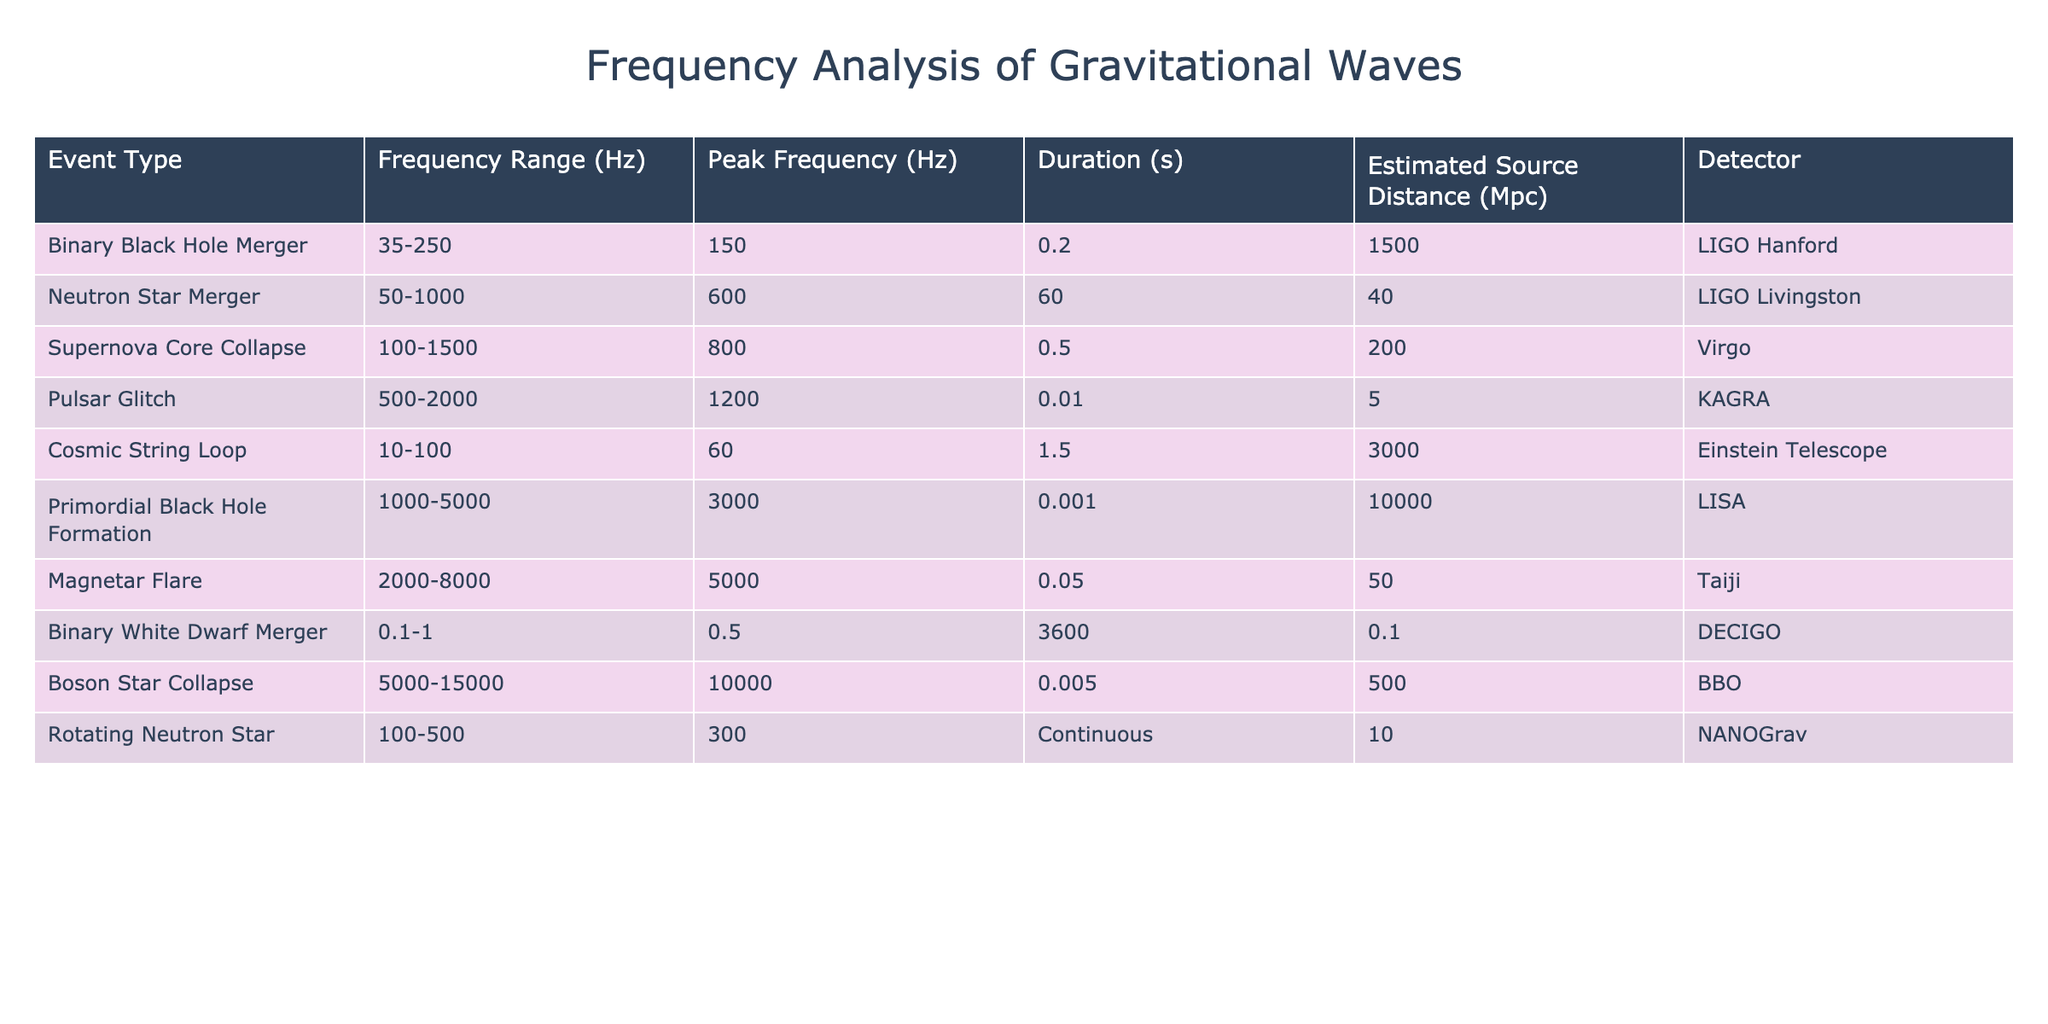What is the peak frequency of the Neutron Star Merger? The table lists the Neutron Star Merger under the "Event Type" with a corresponding "Peak Frequency" of 600 Hz.
Answer: 600 Hz How many events have a duration longer than 1 second? Upon examining the "Duration" column, the events with longer durations are Binary White Dwarf Merger (3600 seconds), Cosmic String Loop (1.5 seconds), and Neutron Star Merger (60 seconds) totaling 3 events.
Answer: 3 Is the peak frequency of the Pulsar Glitch greater than that of the Supernova Core Collapse? The Pulsar Glitch has a peak frequency of 1200 Hz while the Supernova Core Collapse has a peak frequency of 800 Hz. Since 1200 Hz is greater than 800 Hz, the answer is yes.
Answer: Yes What is the difference in peak frequency between the highest and lowest frequency events? The event with the lowest peak frequency is the Binary White Dwarf Merger at 0.5 Hz, and the highest is the Boson Star Collapse at 10000 Hz. The difference is 10000 Hz - 0.5 Hz = 9999.5 Hz.
Answer: 9999.5 Hz What is the average estimated source distance for the events detected? First, list the distances: 1500, 40, 200, 5, 3000, 10000, 50, 0.1, 500. Summing these gives 12695.1 Mpc. There are 9 events, so the average distance is 12695.1 divided by 9, which equals approximately 1410.56 Mpc.
Answer: 1410.56 Mpc Which detector recorded the event with the longest duration? The event with the longest duration is the Binary White Dwarf Merger, which lasted for 3600 seconds, and it was recorded by the DECIGO detector.
Answer: DECIGO Are there any events detected by the Virgo detector with a peak frequency above 800 Hz? The Supernova Core Collapse is recorded by the Virgo detector with a peak frequency of 800 Hz. Since there are no events above this frequency in that detector, the answer is no.
Answer: No How many events have a frequency range that includes low frequencies (below 100 Hz)? The event types that include low frequencies, as shown in the table, are the Cosmic String Loop (10-100 Hz) and the Binary White Dwarf Merger (0.1-1 Hz), totaling 2 events.
Answer: 2 What is the sum of the durations for events detected by the LIGO detectors? The durations for the LIGO detectors are 0.2 seconds (LIGO Hanford) and 60 seconds (LIGO Livingston). Summing these gives 0.2 + 60 = 60.2 seconds.
Answer: 60.2 seconds Which event has the highest estimated source distance, and what is that distance? The event with the highest estimated source distance is the Primordial Black Hole Formation at 10000 Mpc.
Answer: 10000 Mpc 